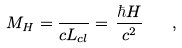<formula> <loc_0><loc_0><loc_500><loc_500>M _ { H } = \frac { } { c L _ { c l } } = \, \frac { \hbar { H } } { c ^ { 2 } } \quad ,</formula> 